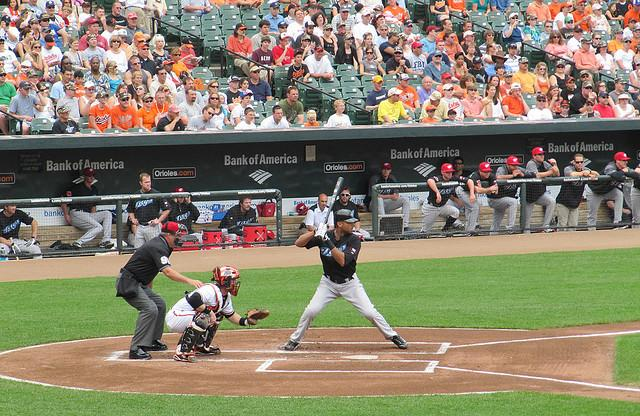What color is the umpire's helmet who is standing with his hand on the catcher's back? red 